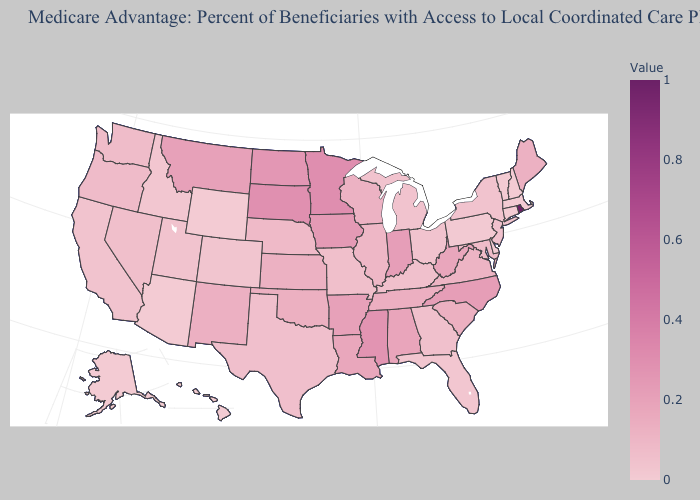Among the states that border Nevada , does Arizona have the lowest value?
Be succinct. Yes. Is the legend a continuous bar?
Answer briefly. Yes. Does Nebraska have the highest value in the USA?
Write a very short answer. No. 